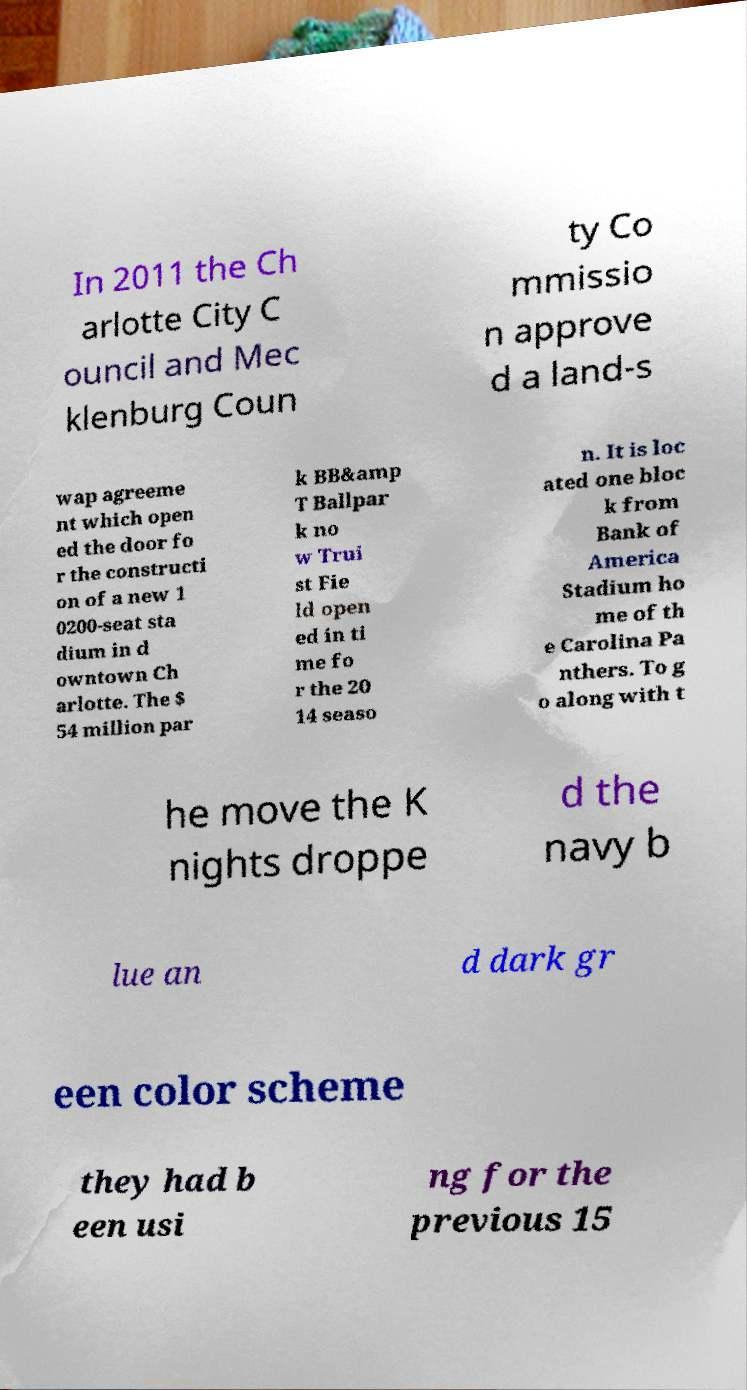There's text embedded in this image that I need extracted. Can you transcribe it verbatim? In 2011 the Ch arlotte City C ouncil and Mec klenburg Coun ty Co mmissio n approve d a land-s wap agreeme nt which open ed the door fo r the constructi on of a new 1 0200-seat sta dium in d owntown Ch arlotte. The $ 54 million par k BB&amp T Ballpar k no w Trui st Fie ld open ed in ti me fo r the 20 14 seaso n. It is loc ated one bloc k from Bank of America Stadium ho me of th e Carolina Pa nthers. To g o along with t he move the K nights droppe d the navy b lue an d dark gr een color scheme they had b een usi ng for the previous 15 